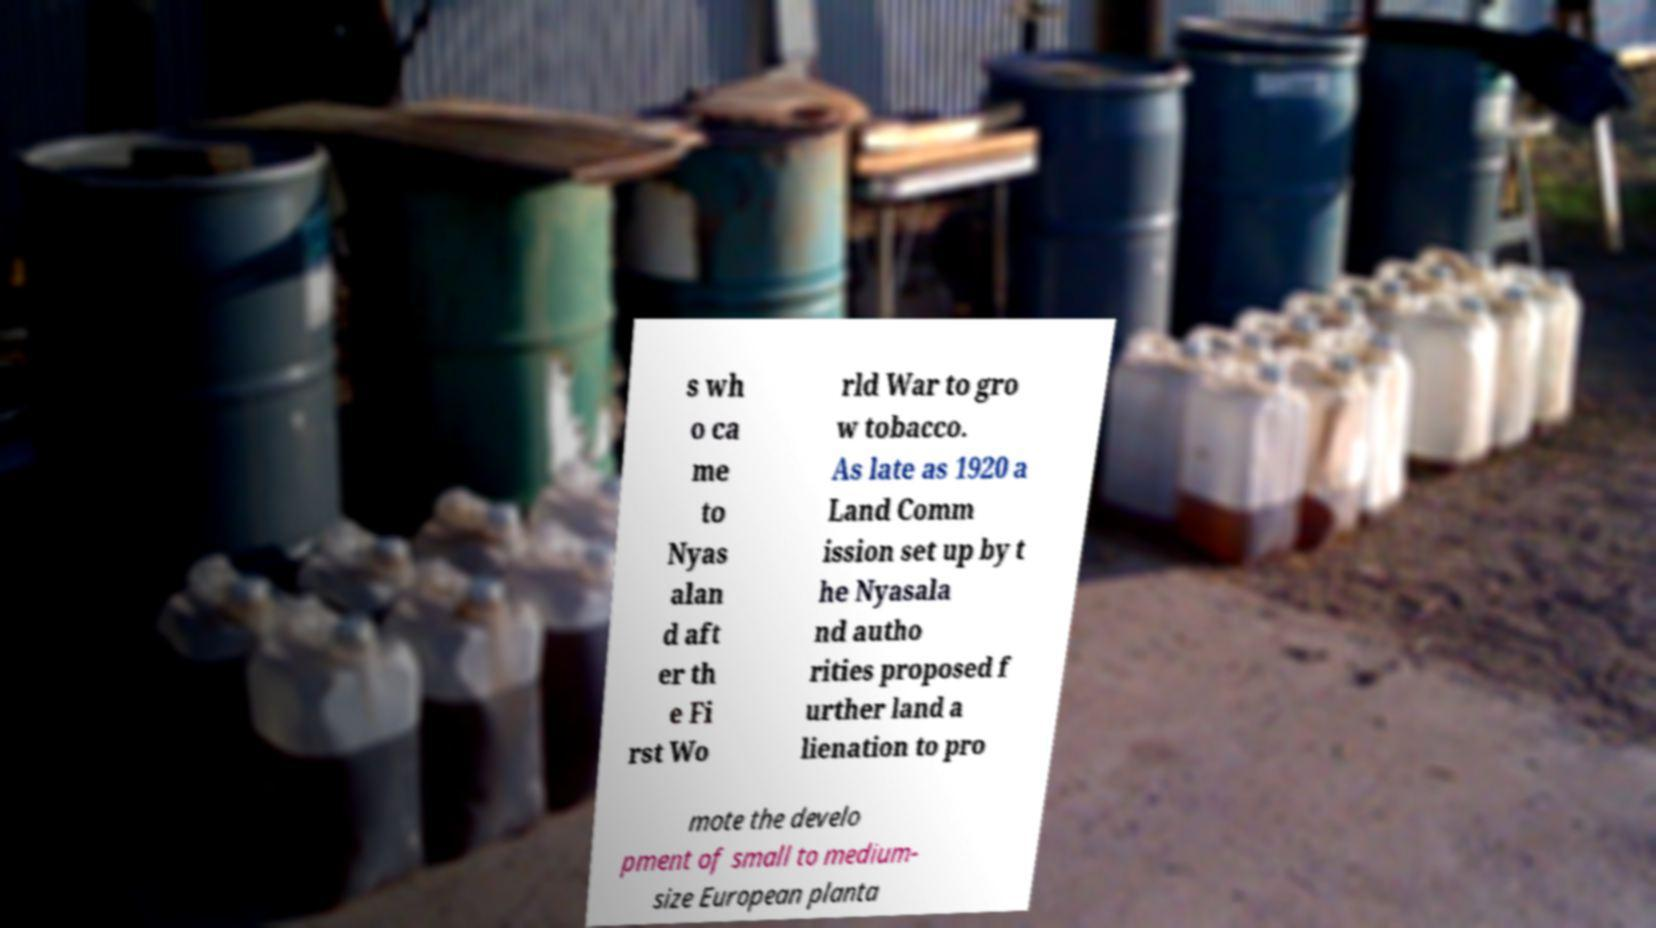Please identify and transcribe the text found in this image. s wh o ca me to Nyas alan d aft er th e Fi rst Wo rld War to gro w tobacco. As late as 1920 a Land Comm ission set up by t he Nyasala nd autho rities proposed f urther land a lienation to pro mote the develo pment of small to medium- size European planta 